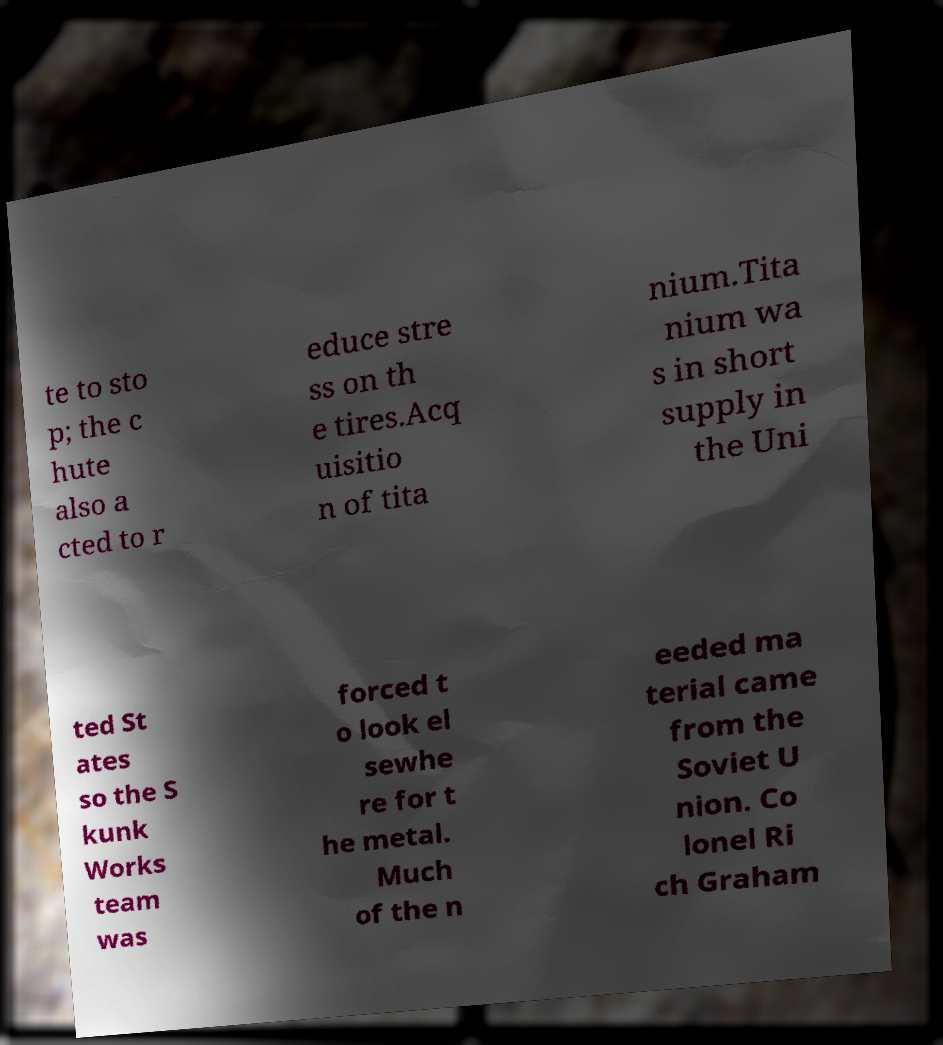Can you read and provide the text displayed in the image?This photo seems to have some interesting text. Can you extract and type it out for me? te to sto p; the c hute also a cted to r educe stre ss on th e tires.Acq uisitio n of tita nium.Tita nium wa s in short supply in the Uni ted St ates so the S kunk Works team was forced t o look el sewhe re for t he metal. Much of the n eeded ma terial came from the Soviet U nion. Co lonel Ri ch Graham 